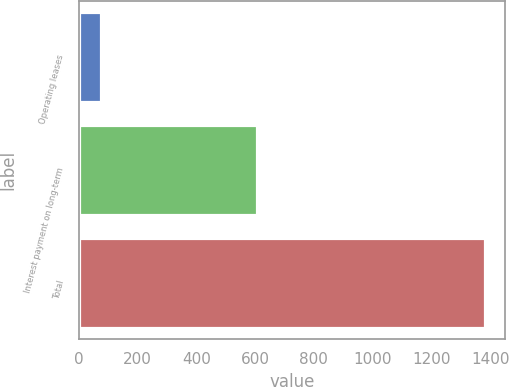<chart> <loc_0><loc_0><loc_500><loc_500><bar_chart><fcel>Operating leases<fcel>Interest payment on long-term<fcel>Total<nl><fcel>76.9<fcel>606<fcel>1382.9<nl></chart> 